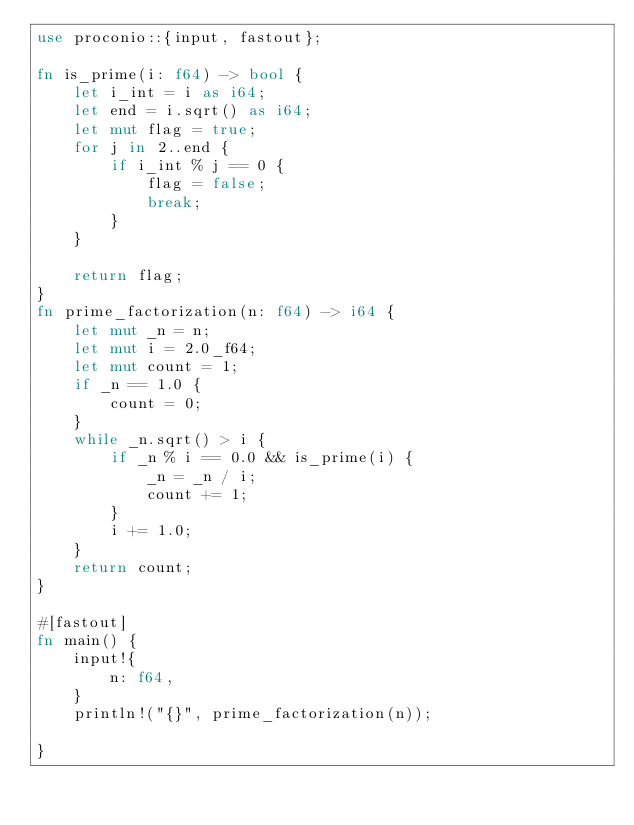Convert code to text. <code><loc_0><loc_0><loc_500><loc_500><_Rust_>use proconio::{input, fastout};

fn is_prime(i: f64) -> bool {
    let i_int = i as i64;
    let end = i.sqrt() as i64;
    let mut flag = true;
    for j in 2..end {
        if i_int % j == 0 {
            flag = false;
            break;
        }
    }

    return flag;
}
fn prime_factorization(n: f64) -> i64 {
    let mut _n = n;
    let mut i = 2.0_f64;
    let mut count = 1;
    if _n == 1.0 {
        count = 0;
    }
    while _n.sqrt() > i {
        if _n % i == 0.0 && is_prime(i) {
            _n = _n / i;
            count += 1;
        }
        i += 1.0;
    }
    return count;
}

#[fastout]
fn main() {
    input!{
        n: f64,
    }
    println!("{}", prime_factorization(n));

}
</code> 